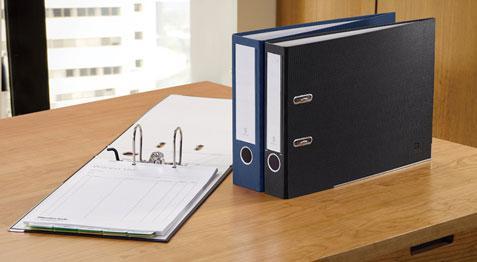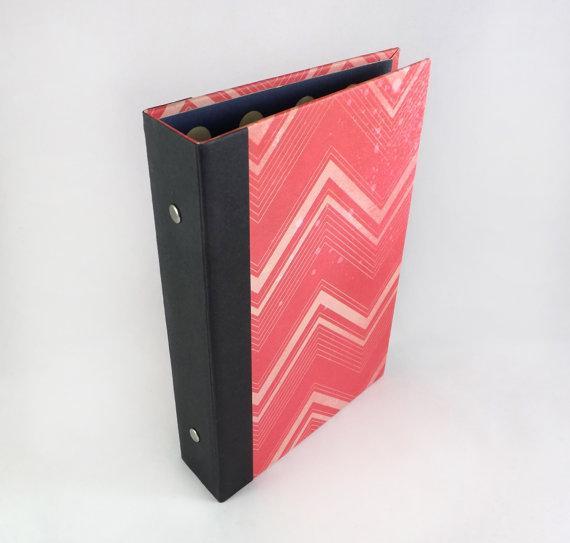The first image is the image on the left, the second image is the image on the right. For the images displayed, is the sentence "There are two black binders on a wooden surface." factually correct? Answer yes or no. Yes. The first image is the image on the left, the second image is the image on the right. Given the left and right images, does the statement "An image includes a black upright binder with a black circle below a white rectangle on its end." hold true? Answer yes or no. Yes. 